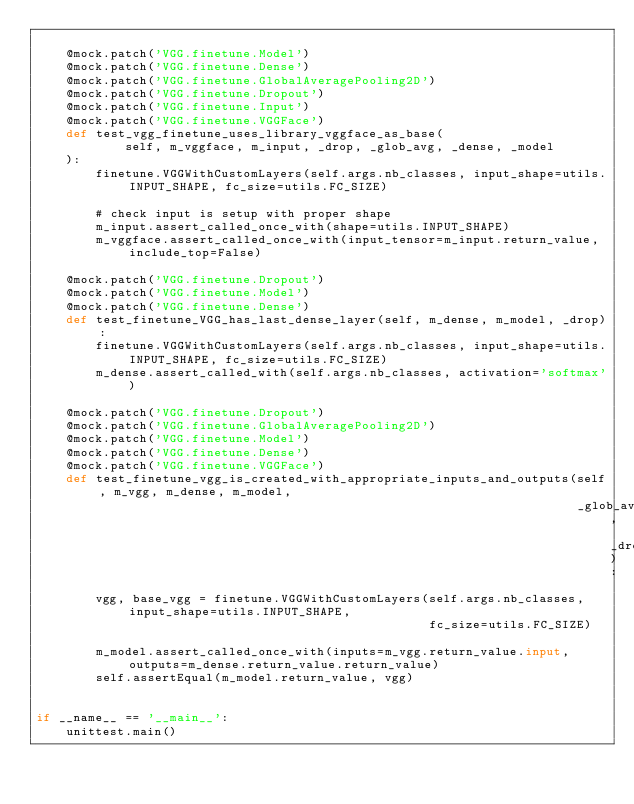<code> <loc_0><loc_0><loc_500><loc_500><_Python_>
    @mock.patch('VGG.finetune.Model')
    @mock.patch('VGG.finetune.Dense')
    @mock.patch('VGG.finetune.GlobalAveragePooling2D')
    @mock.patch('VGG.finetune.Dropout')
    @mock.patch('VGG.finetune.Input')
    @mock.patch('VGG.finetune.VGGFace')
    def test_vgg_finetune_uses_library_vggface_as_base(
            self, m_vggface, m_input, _drop, _glob_avg, _dense, _model
    ):
        finetune.VGGWithCustomLayers(self.args.nb_classes, input_shape=utils.INPUT_SHAPE, fc_size=utils.FC_SIZE)

        # check input is setup with proper shape
        m_input.assert_called_once_with(shape=utils.INPUT_SHAPE)
        m_vggface.assert_called_once_with(input_tensor=m_input.return_value, include_top=False)

    @mock.patch('VGG.finetune.Dropout')
    @mock.patch('VGG.finetune.Model')
    @mock.patch('VGG.finetune.Dense')
    def test_finetune_VGG_has_last_dense_layer(self, m_dense, m_model, _drop):
        finetune.VGGWithCustomLayers(self.args.nb_classes, input_shape=utils.INPUT_SHAPE, fc_size=utils.FC_SIZE)
        m_dense.assert_called_with(self.args.nb_classes, activation='softmax')

    @mock.patch('VGG.finetune.Dropout')
    @mock.patch('VGG.finetune.GlobalAveragePooling2D')
    @mock.patch('VGG.finetune.Model')
    @mock.patch('VGG.finetune.Dense')
    @mock.patch('VGG.finetune.VGGFace')
    def test_finetune_vgg_is_created_with_appropriate_inputs_and_outputs(self, m_vgg, m_dense, m_model,
                                                                         _glob_avg, _drop):
        vgg, base_vgg = finetune.VGGWithCustomLayers(self.args.nb_classes, input_shape=utils.INPUT_SHAPE,
                                                     fc_size=utils.FC_SIZE)

        m_model.assert_called_once_with(inputs=m_vgg.return_value.input, outputs=m_dense.return_value.return_value)
        self.assertEqual(m_model.return_value, vgg)


if __name__ == '__main__':
    unittest.main()
</code> 